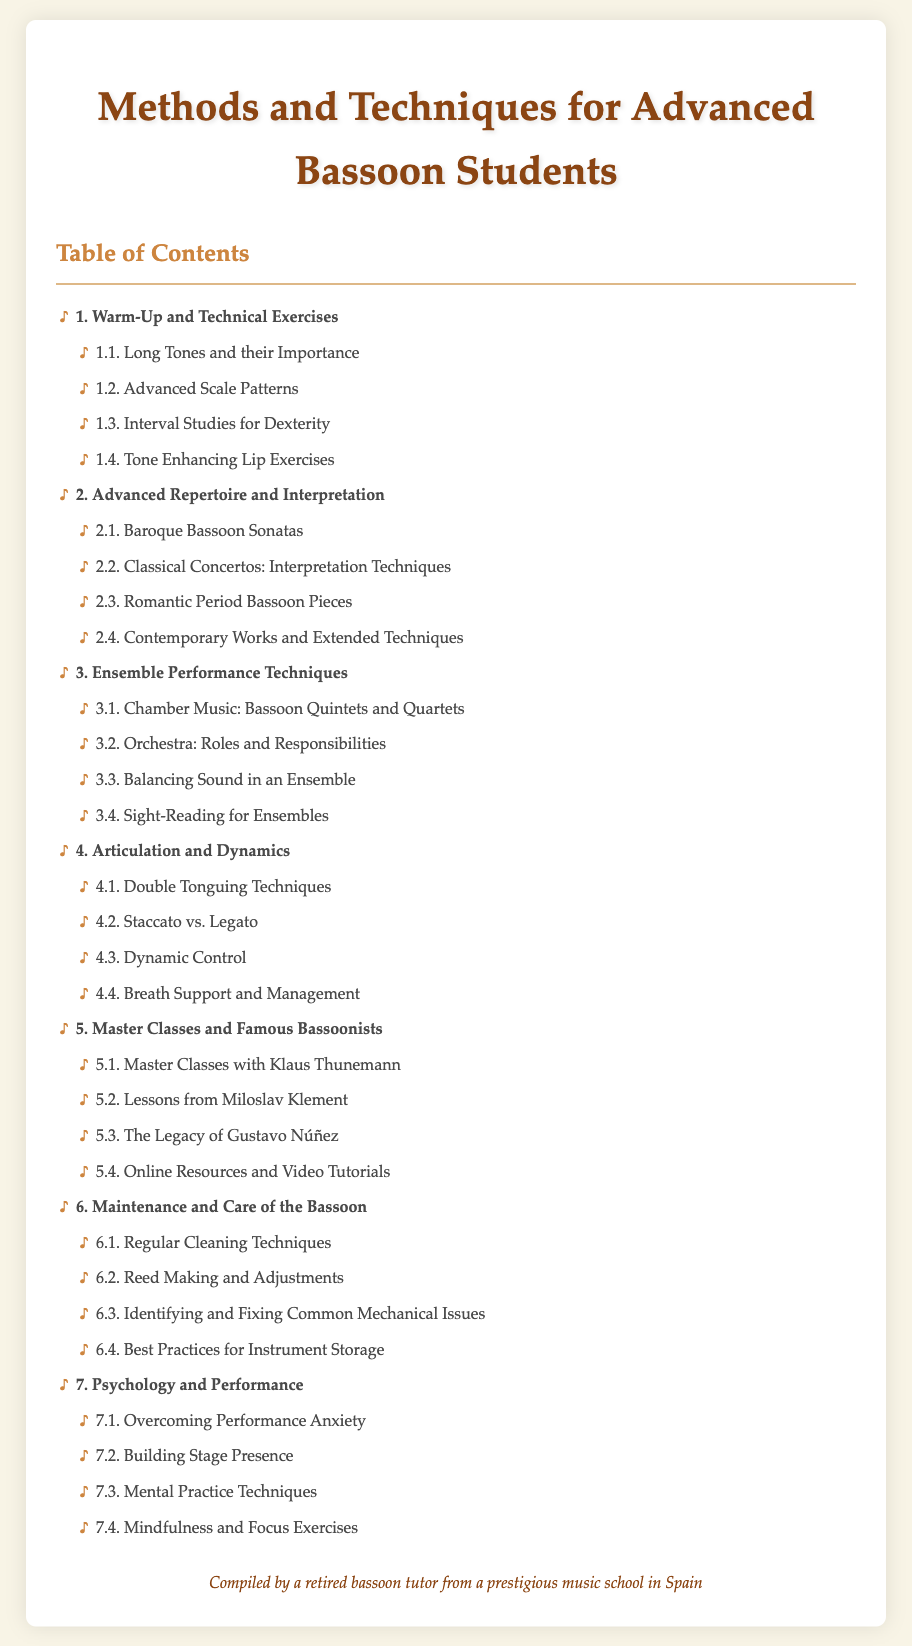What is the title of the document? The title is clearly stated at the top of the document, indicating the subject matter for advanced bassoon students.
Answer: Methods and Techniques for Advanced Bassoon Students How many chapters are listed in the Table of Contents? The number of chapters can be determined by counting the main sections in the Table of Contents.
Answer: 7 What is the first section under Chapter 1? The first section listed under Chapter 1 focuses on a specific prerequisite activity for bassoon players.
Answer: Long Tones and their Importance Who is featured in Master Class 5.1? The specific individual related to the Master Classes can be found in the fifth chapter's first section.
Answer: Klaus Thunemann What topic does Chapter 7 focus on? The subject of Chapter 7 relates to an aspect of performance that affects musicians psychologically.
Answer: Psychology and Performance Which chapter discusses reed making? The chapter that includes reed making is about the care of the bassoon and its components.
Answer: 6 What are the two types of articulation discussed in Chapter 4? The chapter around articulation touches on specific techniques commonly used by bassoonists.
Answer: Double Tonguing and Staccato vs. Legato How many sections are in Chapter 2? The count of sections in Chapter 2 can be deduced from the Table of Contents layout.
Answer: 4 